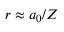Convert formula to latex. <formula><loc_0><loc_0><loc_500><loc_500>r \approx a _ { 0 } / Z</formula> 